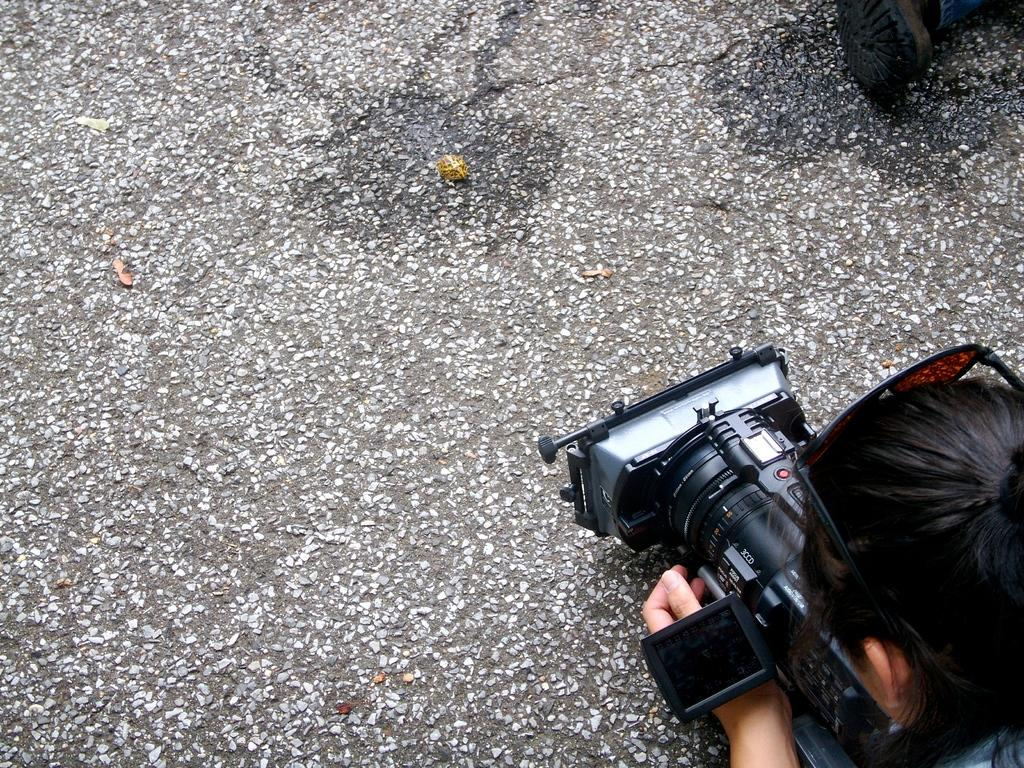What is the person in the image doing? The person in the image is holding a video camera. What can be seen on the ground in the image? There is something on the ground in the image. Can you tell me how many tigers are walking on the sidewalk in the image? There are no tigers or sidewalks present in the image. What news event is the person in the image reporting on? The image does not provide any information about a news event or the person's role in reporting news. 